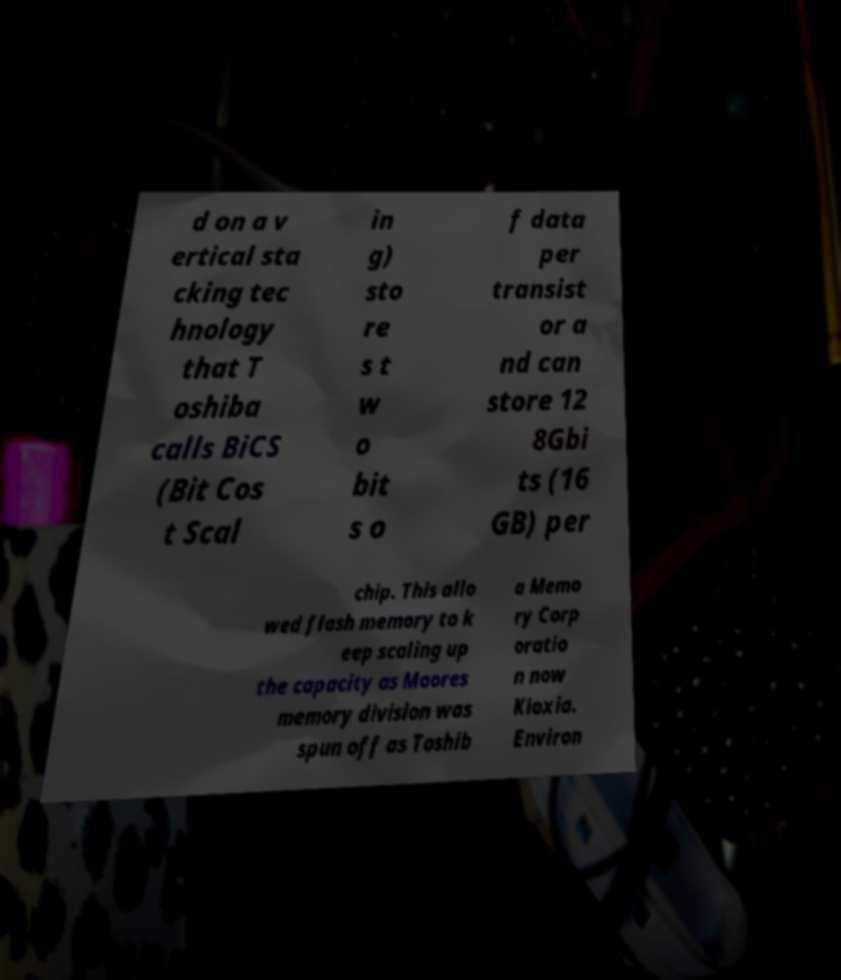There's text embedded in this image that I need extracted. Can you transcribe it verbatim? d on a v ertical sta cking tec hnology that T oshiba calls BiCS (Bit Cos t Scal in g) sto re s t w o bit s o f data per transist or a nd can store 12 8Gbi ts (16 GB) per chip. This allo wed flash memory to k eep scaling up the capacity as Moores memory division was spun off as Toshib a Memo ry Corp oratio n now Kioxia. Environ 